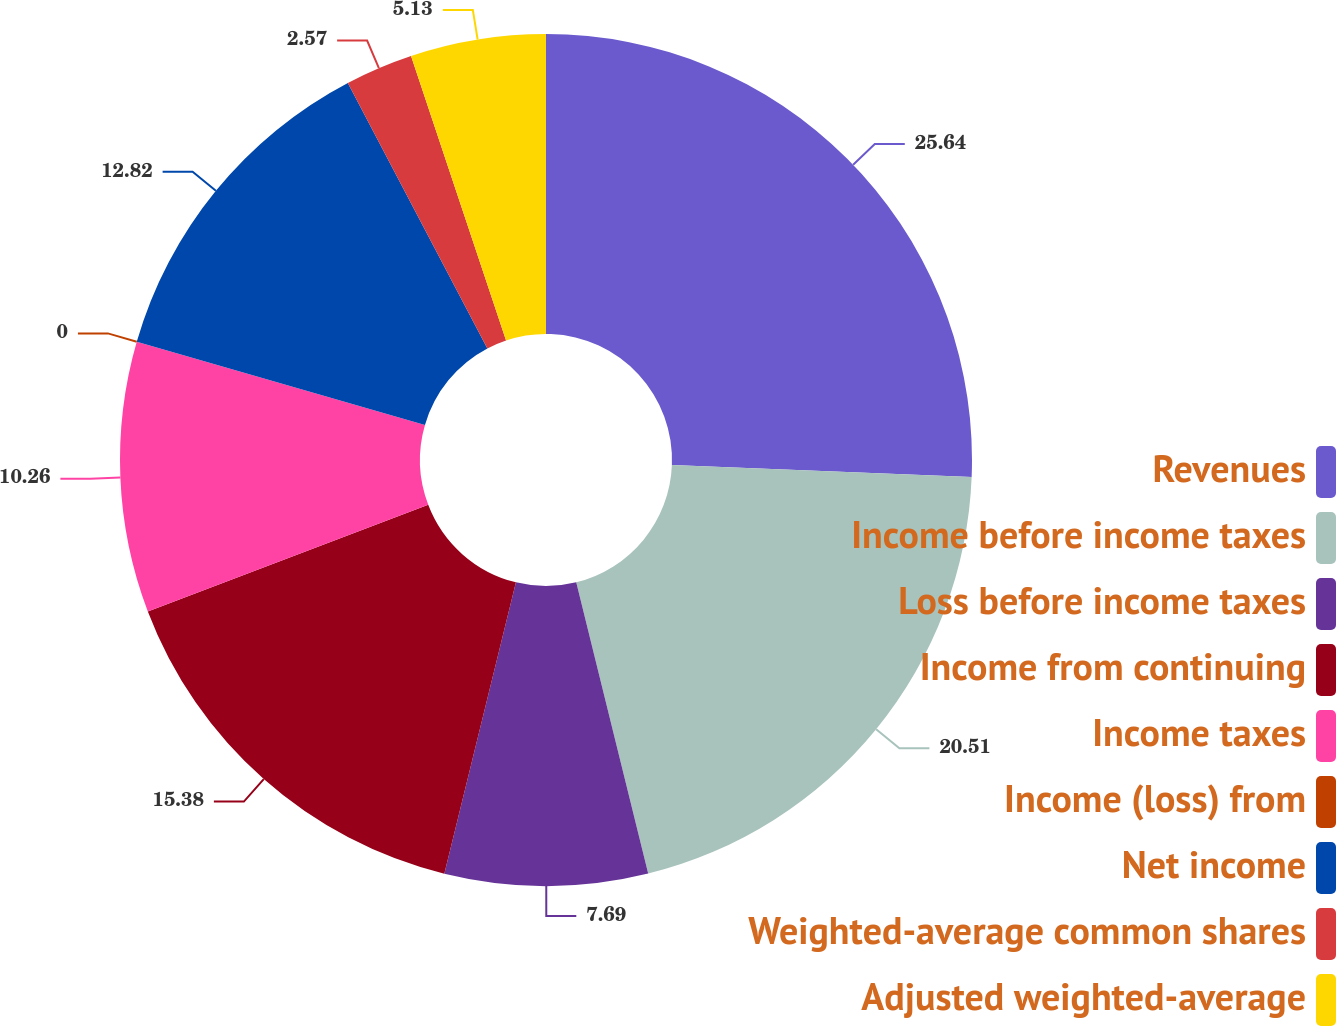Convert chart to OTSL. <chart><loc_0><loc_0><loc_500><loc_500><pie_chart><fcel>Revenues<fcel>Income before income taxes<fcel>Loss before income taxes<fcel>Income from continuing<fcel>Income taxes<fcel>Income (loss) from<fcel>Net income<fcel>Weighted-average common shares<fcel>Adjusted weighted-average<nl><fcel>25.63%<fcel>20.51%<fcel>7.69%<fcel>15.38%<fcel>10.26%<fcel>0.0%<fcel>12.82%<fcel>2.57%<fcel>5.13%<nl></chart> 